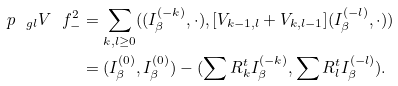Convert formula to latex. <formula><loc_0><loc_0><loc_500><loc_500>\ p _ { \ g l } V \ f ^ { 2 } _ { - } & = \sum _ { k , l \geq 0 } ( ( I _ { \beta } ^ { ( - k ) } , \cdot ) , [ V _ { k - 1 , l } + V _ { k , l - 1 } ] ( I _ { \beta } ^ { ( - l ) } , \cdot ) ) \\ & = ( I _ { \beta } ^ { ( 0 ) } , I _ { \beta } ^ { ( 0 ) } ) - ( \sum R ^ { t } _ { k } I _ { \beta } ^ { ( - k ) } , \sum R ^ { t } _ { l } I _ { \beta } ^ { ( - l ) } ) .</formula> 